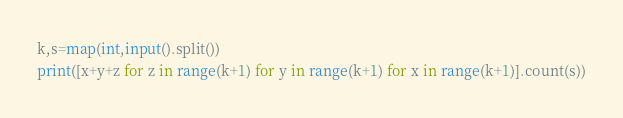Convert code to text. <code><loc_0><loc_0><loc_500><loc_500><_Python_>k,s=map(int,input().split())
print([x+y+z for z in range(k+1) for y in range(k+1) for x in range(k+1)].count(s))</code> 